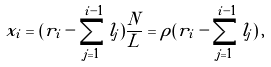<formula> <loc_0><loc_0><loc_500><loc_500>x _ { i } = ( r _ { i } - \sum _ { j = 1 } ^ { i - 1 } l _ { j } ) \frac { N } { L } = \rho ( r _ { i } - \sum _ { j = 1 } ^ { i - 1 } l _ { j } ) \, ,</formula> 